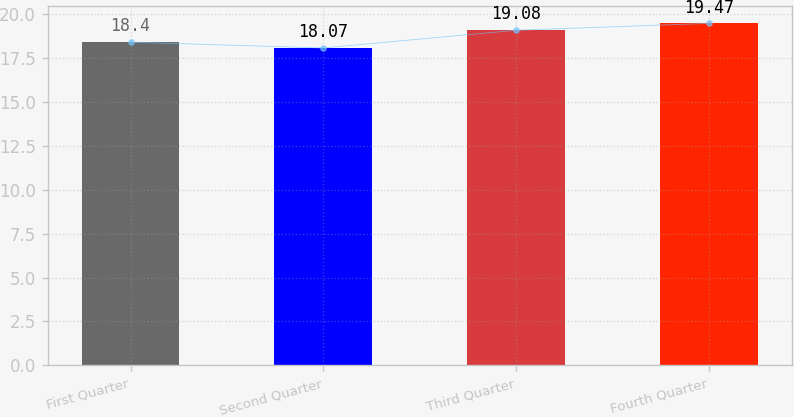Convert chart to OTSL. <chart><loc_0><loc_0><loc_500><loc_500><bar_chart><fcel>First Quarter<fcel>Second Quarter<fcel>Third Quarter<fcel>Fourth Quarter<nl><fcel>18.4<fcel>18.07<fcel>19.08<fcel>19.47<nl></chart> 